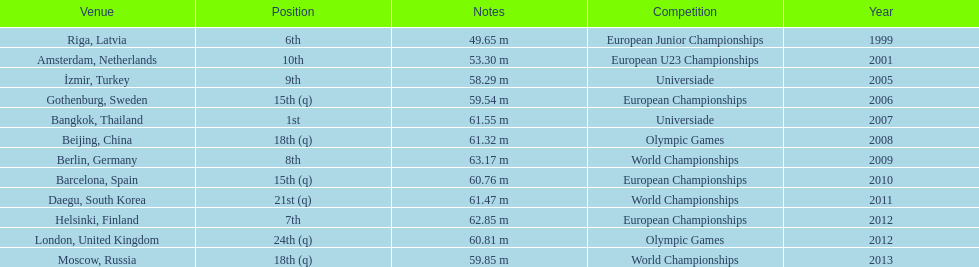Could you parse the entire table? {'header': ['Venue', 'Position', 'Notes', 'Competition', 'Year'], 'rows': [['Riga, Latvia', '6th', '49.65 m', 'European Junior Championships', '1999'], ['Amsterdam, Netherlands', '10th', '53.30 m', 'European U23 Championships', '2001'], ['İzmir, Turkey', '9th', '58.29 m', 'Universiade', '2005'], ['Gothenburg, Sweden', '15th (q)', '59.54 m', 'European Championships', '2006'], ['Bangkok, Thailand', '1st', '61.55 m', 'Universiade', '2007'], ['Beijing, China', '18th (q)', '61.32 m', 'Olympic Games', '2008'], ['Berlin, Germany', '8th', '63.17 m', 'World Championships', '2009'], ['Barcelona, Spain', '15th (q)', '60.76 m', 'European Championships', '2010'], ['Daegu, South Korea', '21st (q)', '61.47 m', 'World Championships', '2011'], ['Helsinki, Finland', '7th', '62.85 m', 'European Championships', '2012'], ['London, United Kingdom', '24th (q)', '60.81 m', 'Olympic Games', '2012'], ['Moscow, Russia', '18th (q)', '59.85 m', 'World Championships', '2013']]} What was the last competition he was in before the 2012 olympics? European Championships. 